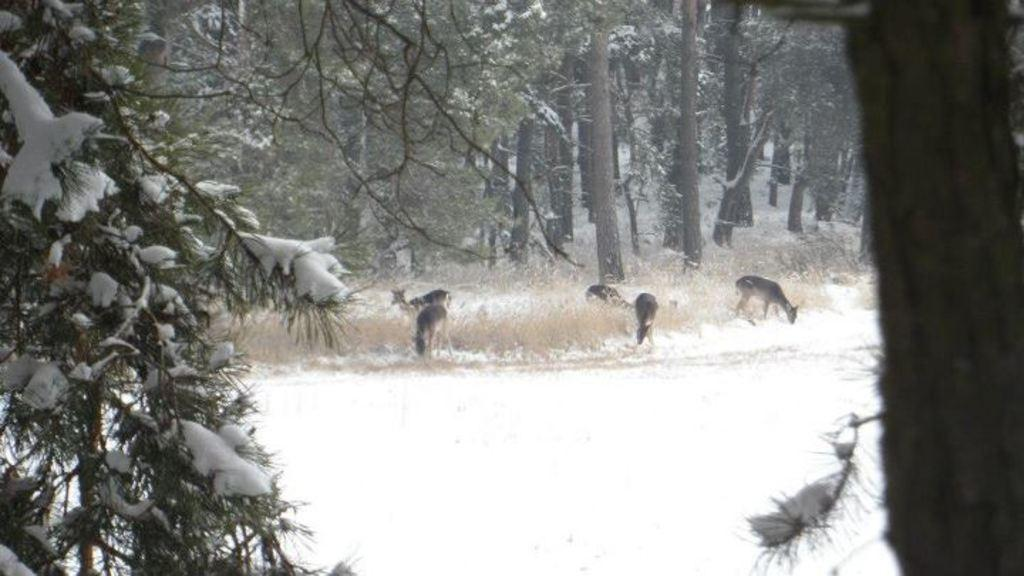What type of weather condition is depicted in the image? There is snow in the image, indicating a cold and snowy environment. What type of animals can be seen in the image? There are animals in the image, but their specific species is not mentioned in the facts. What type of vegetation is present in the image? There is dried grass in the image. What type of natural structures are visible in the image? There are trees in the image. How many jars of waste are visible in the image? There is no mention of jars of waste in the image; the facts only mention snow, animals, dried grass, and trees. What type of jam is being spread on the dried grass in the image? There is no jam or any food item mentioned in the image; the facts only mention snow, animals, dried grass, and trees. 